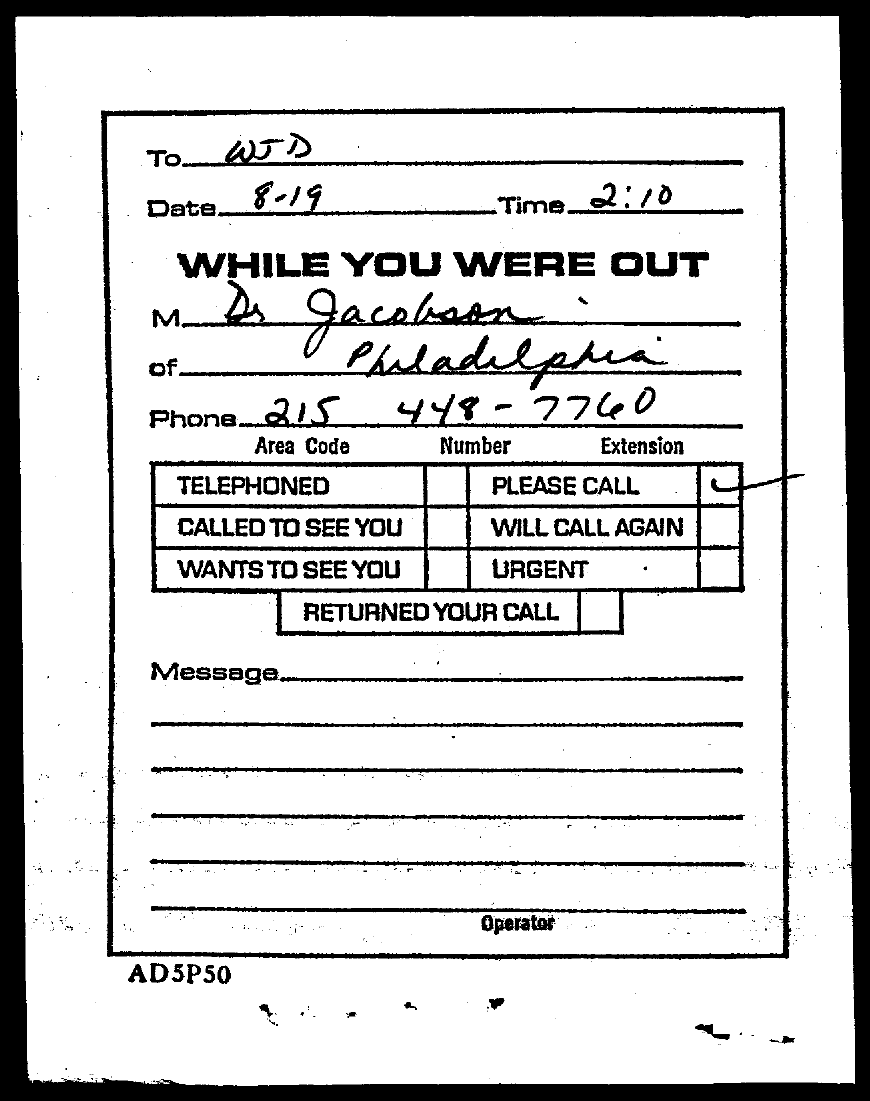Highlight a few significant elements in this photo. The document states that the date mentioned is 8-19. The time mentioned in this document is 2:10. The phone number of Dr. Jacobson is 215 448-7760. The document is addressed to WJD. 